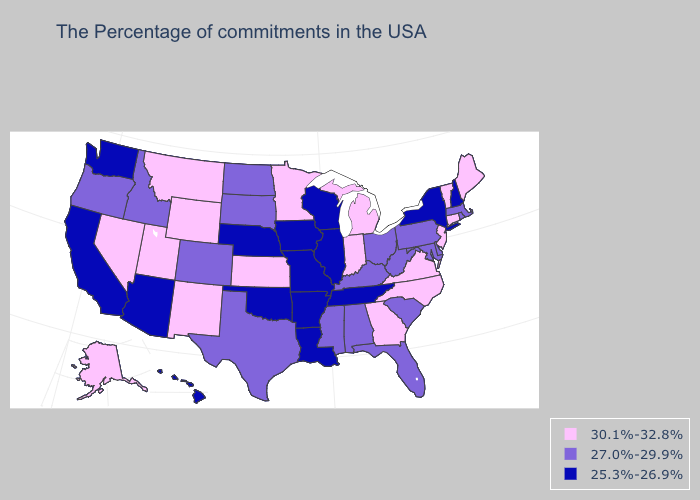Name the states that have a value in the range 30.1%-32.8%?
Short answer required. Maine, Vermont, Connecticut, New Jersey, Virginia, North Carolina, Georgia, Michigan, Indiana, Minnesota, Kansas, Wyoming, New Mexico, Utah, Montana, Nevada, Alaska. Which states have the lowest value in the USA?
Concise answer only. New Hampshire, New York, Tennessee, Wisconsin, Illinois, Louisiana, Missouri, Arkansas, Iowa, Nebraska, Oklahoma, Arizona, California, Washington, Hawaii. Which states have the lowest value in the USA?
Give a very brief answer. New Hampshire, New York, Tennessee, Wisconsin, Illinois, Louisiana, Missouri, Arkansas, Iowa, Nebraska, Oklahoma, Arizona, California, Washington, Hawaii. Does Louisiana have the same value as Nevada?
Answer briefly. No. What is the value of Tennessee?
Answer briefly. 25.3%-26.9%. What is the value of Indiana?
Concise answer only. 30.1%-32.8%. What is the value of Delaware?
Quick response, please. 27.0%-29.9%. Does North Dakota have a higher value than Utah?
Answer briefly. No. Name the states that have a value in the range 25.3%-26.9%?
Write a very short answer. New Hampshire, New York, Tennessee, Wisconsin, Illinois, Louisiana, Missouri, Arkansas, Iowa, Nebraska, Oklahoma, Arizona, California, Washington, Hawaii. Is the legend a continuous bar?
Keep it brief. No. Does Virginia have the highest value in the South?
Concise answer only. Yes. Does Oklahoma have the lowest value in the USA?
Quick response, please. Yes. Does Wisconsin have the highest value in the USA?
Short answer required. No. Which states have the lowest value in the USA?
Give a very brief answer. New Hampshire, New York, Tennessee, Wisconsin, Illinois, Louisiana, Missouri, Arkansas, Iowa, Nebraska, Oklahoma, Arizona, California, Washington, Hawaii. Name the states that have a value in the range 30.1%-32.8%?
Keep it brief. Maine, Vermont, Connecticut, New Jersey, Virginia, North Carolina, Georgia, Michigan, Indiana, Minnesota, Kansas, Wyoming, New Mexico, Utah, Montana, Nevada, Alaska. 